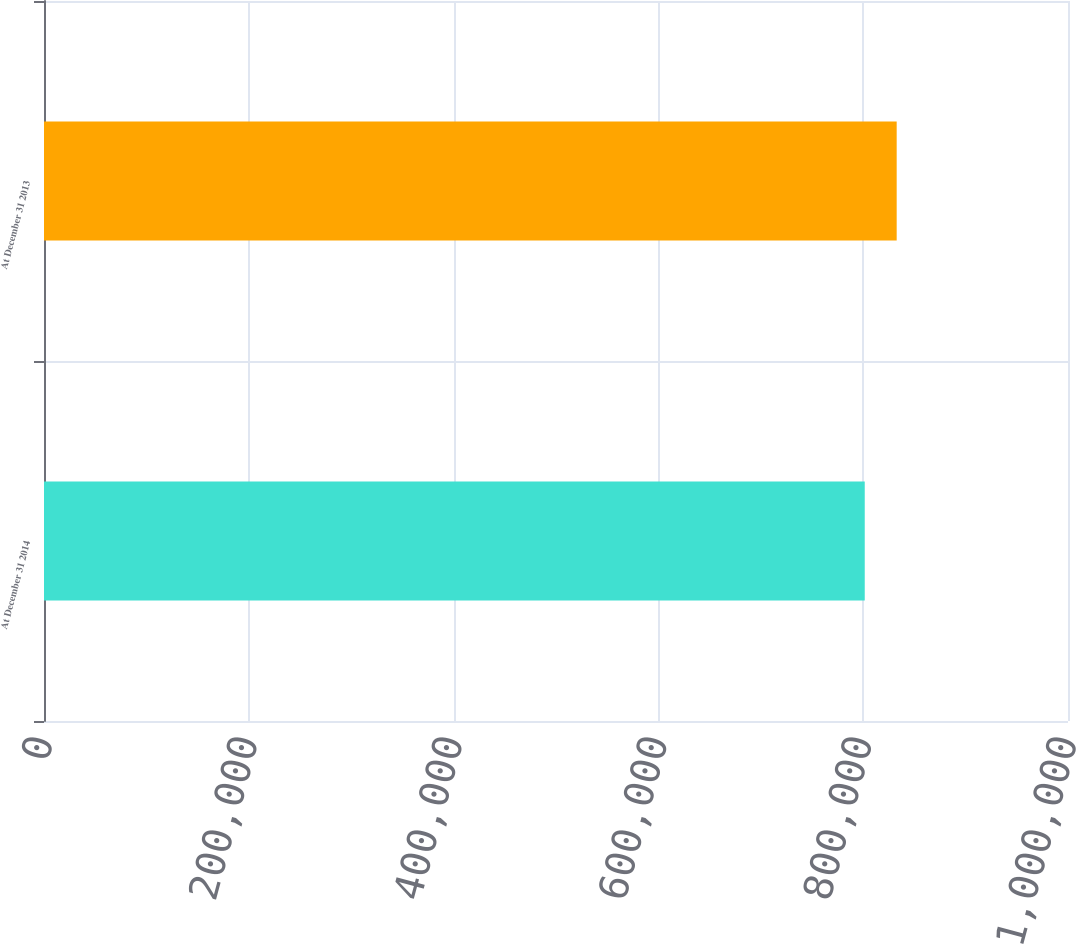Convert chart to OTSL. <chart><loc_0><loc_0><loc_500><loc_500><bar_chart><fcel>At December 31 2014<fcel>At December 31 2013<nl><fcel>801510<fcel>832702<nl></chart> 